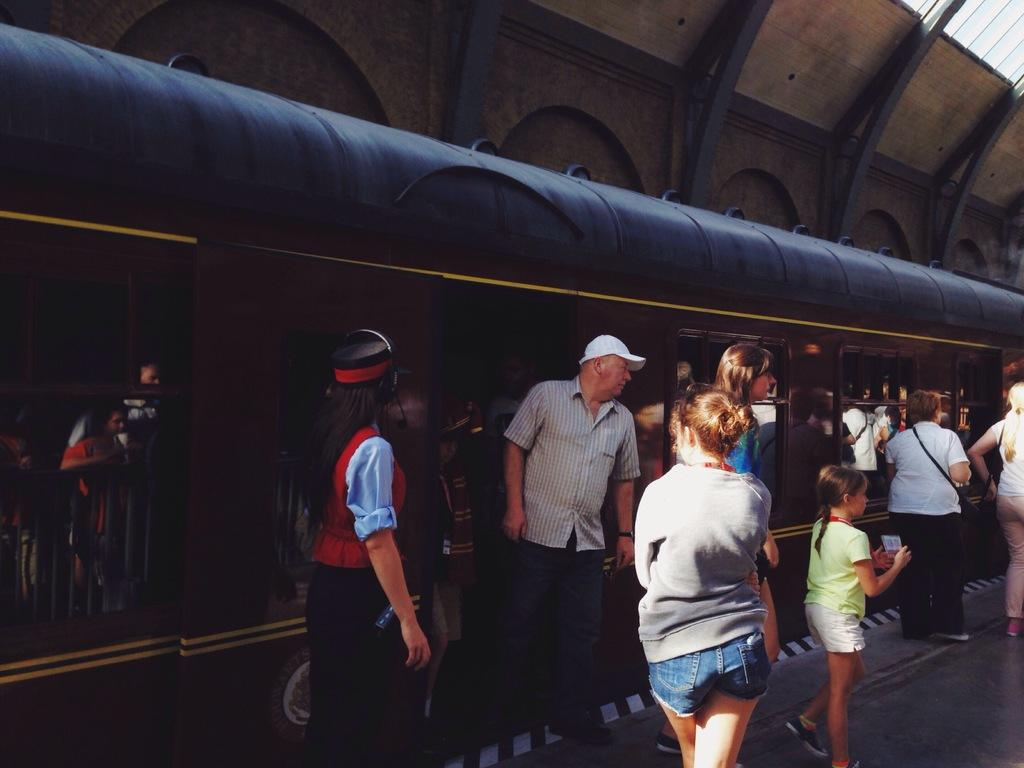What is the main subject in the middle of the image? There is a train in the middle of the image. What is located at the top of the image? There is a roof at the top of the image. Where are the people located in the image? There are people standing on a platform at the bottom of the image. Are there any dinosaurs visible in the image? No, there are no dinosaurs present in the image. What type of destruction can be seen in the image? There is no destruction visible in the image; it appears to be a normal train station scene. 